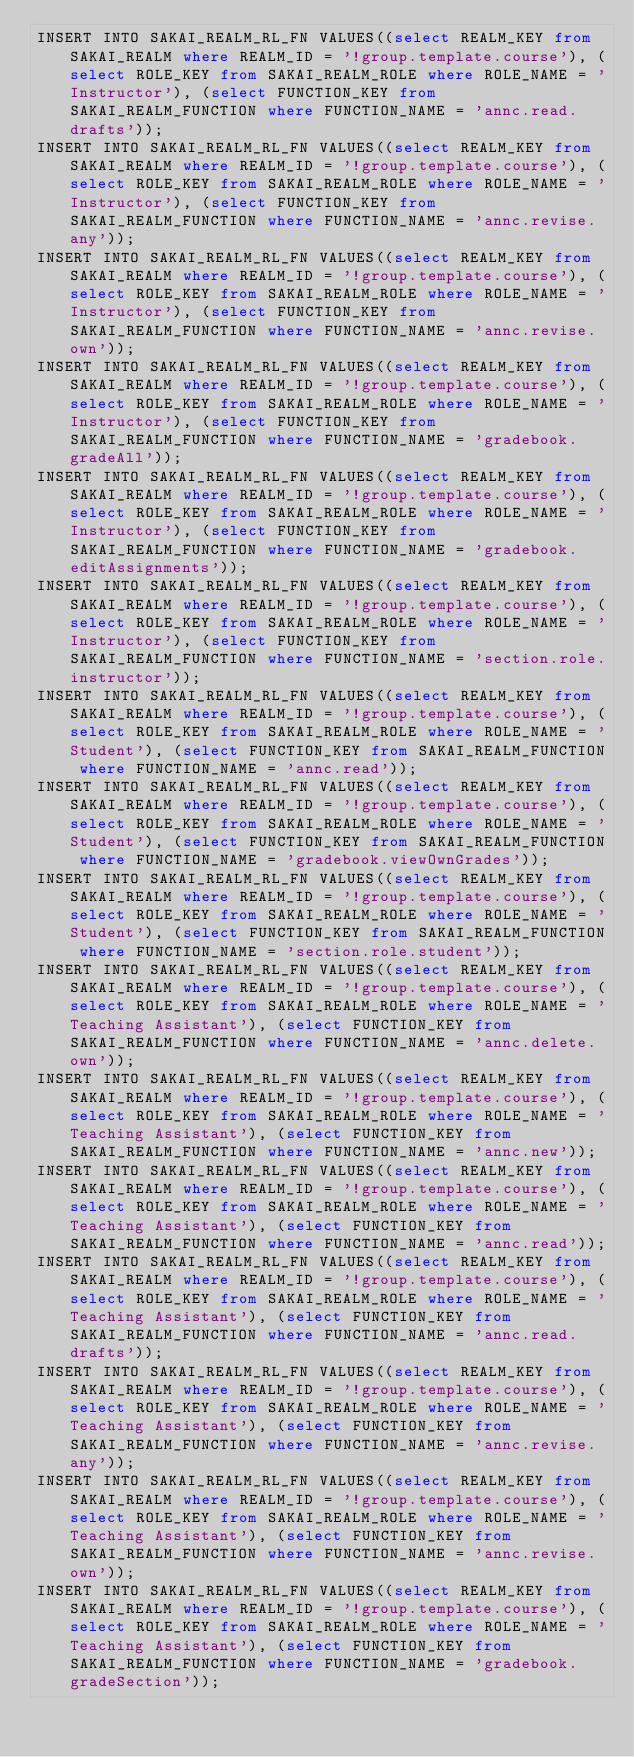<code> <loc_0><loc_0><loc_500><loc_500><_SQL_>INSERT INTO SAKAI_REALM_RL_FN VALUES((select REALM_KEY from SAKAI_REALM where REALM_ID = '!group.template.course'), (select ROLE_KEY from SAKAI_REALM_ROLE where ROLE_NAME = 'Instructor'), (select FUNCTION_KEY from SAKAI_REALM_FUNCTION where FUNCTION_NAME = 'annc.read.drafts'));
INSERT INTO SAKAI_REALM_RL_FN VALUES((select REALM_KEY from SAKAI_REALM where REALM_ID = '!group.template.course'), (select ROLE_KEY from SAKAI_REALM_ROLE where ROLE_NAME = 'Instructor'), (select FUNCTION_KEY from SAKAI_REALM_FUNCTION where FUNCTION_NAME = 'annc.revise.any'));
INSERT INTO SAKAI_REALM_RL_FN VALUES((select REALM_KEY from SAKAI_REALM where REALM_ID = '!group.template.course'), (select ROLE_KEY from SAKAI_REALM_ROLE where ROLE_NAME = 'Instructor'), (select FUNCTION_KEY from SAKAI_REALM_FUNCTION where FUNCTION_NAME = 'annc.revise.own'));
INSERT INTO SAKAI_REALM_RL_FN VALUES((select REALM_KEY from SAKAI_REALM where REALM_ID = '!group.template.course'), (select ROLE_KEY from SAKAI_REALM_ROLE where ROLE_NAME = 'Instructor'), (select FUNCTION_KEY from SAKAI_REALM_FUNCTION where FUNCTION_NAME = 'gradebook.gradeAll'));
INSERT INTO SAKAI_REALM_RL_FN VALUES((select REALM_KEY from SAKAI_REALM where REALM_ID = '!group.template.course'), (select ROLE_KEY from SAKAI_REALM_ROLE where ROLE_NAME = 'Instructor'), (select FUNCTION_KEY from SAKAI_REALM_FUNCTION where FUNCTION_NAME = 'gradebook.editAssignments'));
INSERT INTO SAKAI_REALM_RL_FN VALUES((select REALM_KEY from SAKAI_REALM where REALM_ID = '!group.template.course'), (select ROLE_KEY from SAKAI_REALM_ROLE where ROLE_NAME = 'Instructor'), (select FUNCTION_KEY from SAKAI_REALM_FUNCTION where FUNCTION_NAME = 'section.role.instructor'));
INSERT INTO SAKAI_REALM_RL_FN VALUES((select REALM_KEY from SAKAI_REALM where REALM_ID = '!group.template.course'), (select ROLE_KEY from SAKAI_REALM_ROLE where ROLE_NAME = 'Student'), (select FUNCTION_KEY from SAKAI_REALM_FUNCTION where FUNCTION_NAME = 'annc.read'));
INSERT INTO SAKAI_REALM_RL_FN VALUES((select REALM_KEY from SAKAI_REALM where REALM_ID = '!group.template.course'), (select ROLE_KEY from SAKAI_REALM_ROLE where ROLE_NAME = 'Student'), (select FUNCTION_KEY from SAKAI_REALM_FUNCTION where FUNCTION_NAME = 'gradebook.viewOwnGrades'));
INSERT INTO SAKAI_REALM_RL_FN VALUES((select REALM_KEY from SAKAI_REALM where REALM_ID = '!group.template.course'), (select ROLE_KEY from SAKAI_REALM_ROLE where ROLE_NAME = 'Student'), (select FUNCTION_KEY from SAKAI_REALM_FUNCTION where FUNCTION_NAME = 'section.role.student'));
INSERT INTO SAKAI_REALM_RL_FN VALUES((select REALM_KEY from SAKAI_REALM where REALM_ID = '!group.template.course'), (select ROLE_KEY from SAKAI_REALM_ROLE where ROLE_NAME = 'Teaching Assistant'), (select FUNCTION_KEY from SAKAI_REALM_FUNCTION where FUNCTION_NAME = 'annc.delete.own'));
INSERT INTO SAKAI_REALM_RL_FN VALUES((select REALM_KEY from SAKAI_REALM where REALM_ID = '!group.template.course'), (select ROLE_KEY from SAKAI_REALM_ROLE where ROLE_NAME = 'Teaching Assistant'), (select FUNCTION_KEY from SAKAI_REALM_FUNCTION where FUNCTION_NAME = 'annc.new'));
INSERT INTO SAKAI_REALM_RL_FN VALUES((select REALM_KEY from SAKAI_REALM where REALM_ID = '!group.template.course'), (select ROLE_KEY from SAKAI_REALM_ROLE where ROLE_NAME = 'Teaching Assistant'), (select FUNCTION_KEY from SAKAI_REALM_FUNCTION where FUNCTION_NAME = 'annc.read'));
INSERT INTO SAKAI_REALM_RL_FN VALUES((select REALM_KEY from SAKAI_REALM where REALM_ID = '!group.template.course'), (select ROLE_KEY from SAKAI_REALM_ROLE where ROLE_NAME = 'Teaching Assistant'), (select FUNCTION_KEY from SAKAI_REALM_FUNCTION where FUNCTION_NAME = 'annc.read.drafts'));
INSERT INTO SAKAI_REALM_RL_FN VALUES((select REALM_KEY from SAKAI_REALM where REALM_ID = '!group.template.course'), (select ROLE_KEY from SAKAI_REALM_ROLE where ROLE_NAME = 'Teaching Assistant'), (select FUNCTION_KEY from SAKAI_REALM_FUNCTION where FUNCTION_NAME = 'annc.revise.any'));
INSERT INTO SAKAI_REALM_RL_FN VALUES((select REALM_KEY from SAKAI_REALM where REALM_ID = '!group.template.course'), (select ROLE_KEY from SAKAI_REALM_ROLE where ROLE_NAME = 'Teaching Assistant'), (select FUNCTION_KEY from SAKAI_REALM_FUNCTION where FUNCTION_NAME = 'annc.revise.own'));
INSERT INTO SAKAI_REALM_RL_FN VALUES((select REALM_KEY from SAKAI_REALM where REALM_ID = '!group.template.course'), (select ROLE_KEY from SAKAI_REALM_ROLE where ROLE_NAME = 'Teaching Assistant'), (select FUNCTION_KEY from SAKAI_REALM_FUNCTION where FUNCTION_NAME = 'gradebook.gradeSection'));</code> 